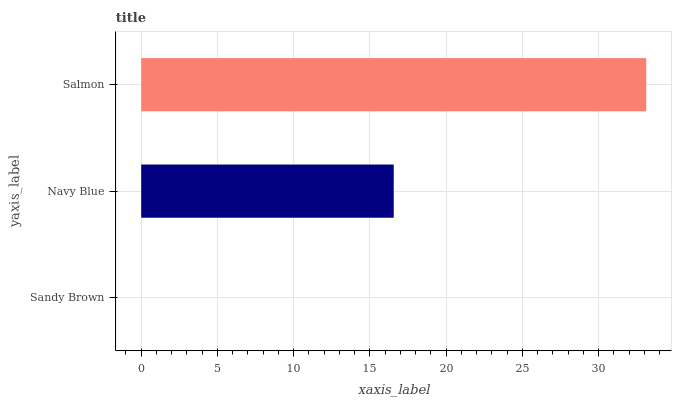Is Sandy Brown the minimum?
Answer yes or no. Yes. Is Salmon the maximum?
Answer yes or no. Yes. Is Navy Blue the minimum?
Answer yes or no. No. Is Navy Blue the maximum?
Answer yes or no. No. Is Navy Blue greater than Sandy Brown?
Answer yes or no. Yes. Is Sandy Brown less than Navy Blue?
Answer yes or no. Yes. Is Sandy Brown greater than Navy Blue?
Answer yes or no. No. Is Navy Blue less than Sandy Brown?
Answer yes or no. No. Is Navy Blue the high median?
Answer yes or no. Yes. Is Navy Blue the low median?
Answer yes or no. Yes. Is Salmon the high median?
Answer yes or no. No. Is Salmon the low median?
Answer yes or no. No. 